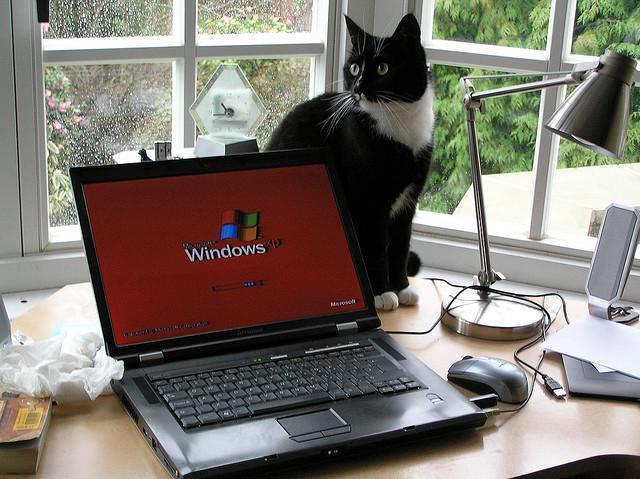How many cats are in the picture?
Give a very brief answer. 1. How many clocks are there?
Give a very brief answer. 1. How many mice are there?
Give a very brief answer. 1. How many laptops can be seen?
Give a very brief answer. 1. How many bottles are on the table?
Give a very brief answer. 0. 